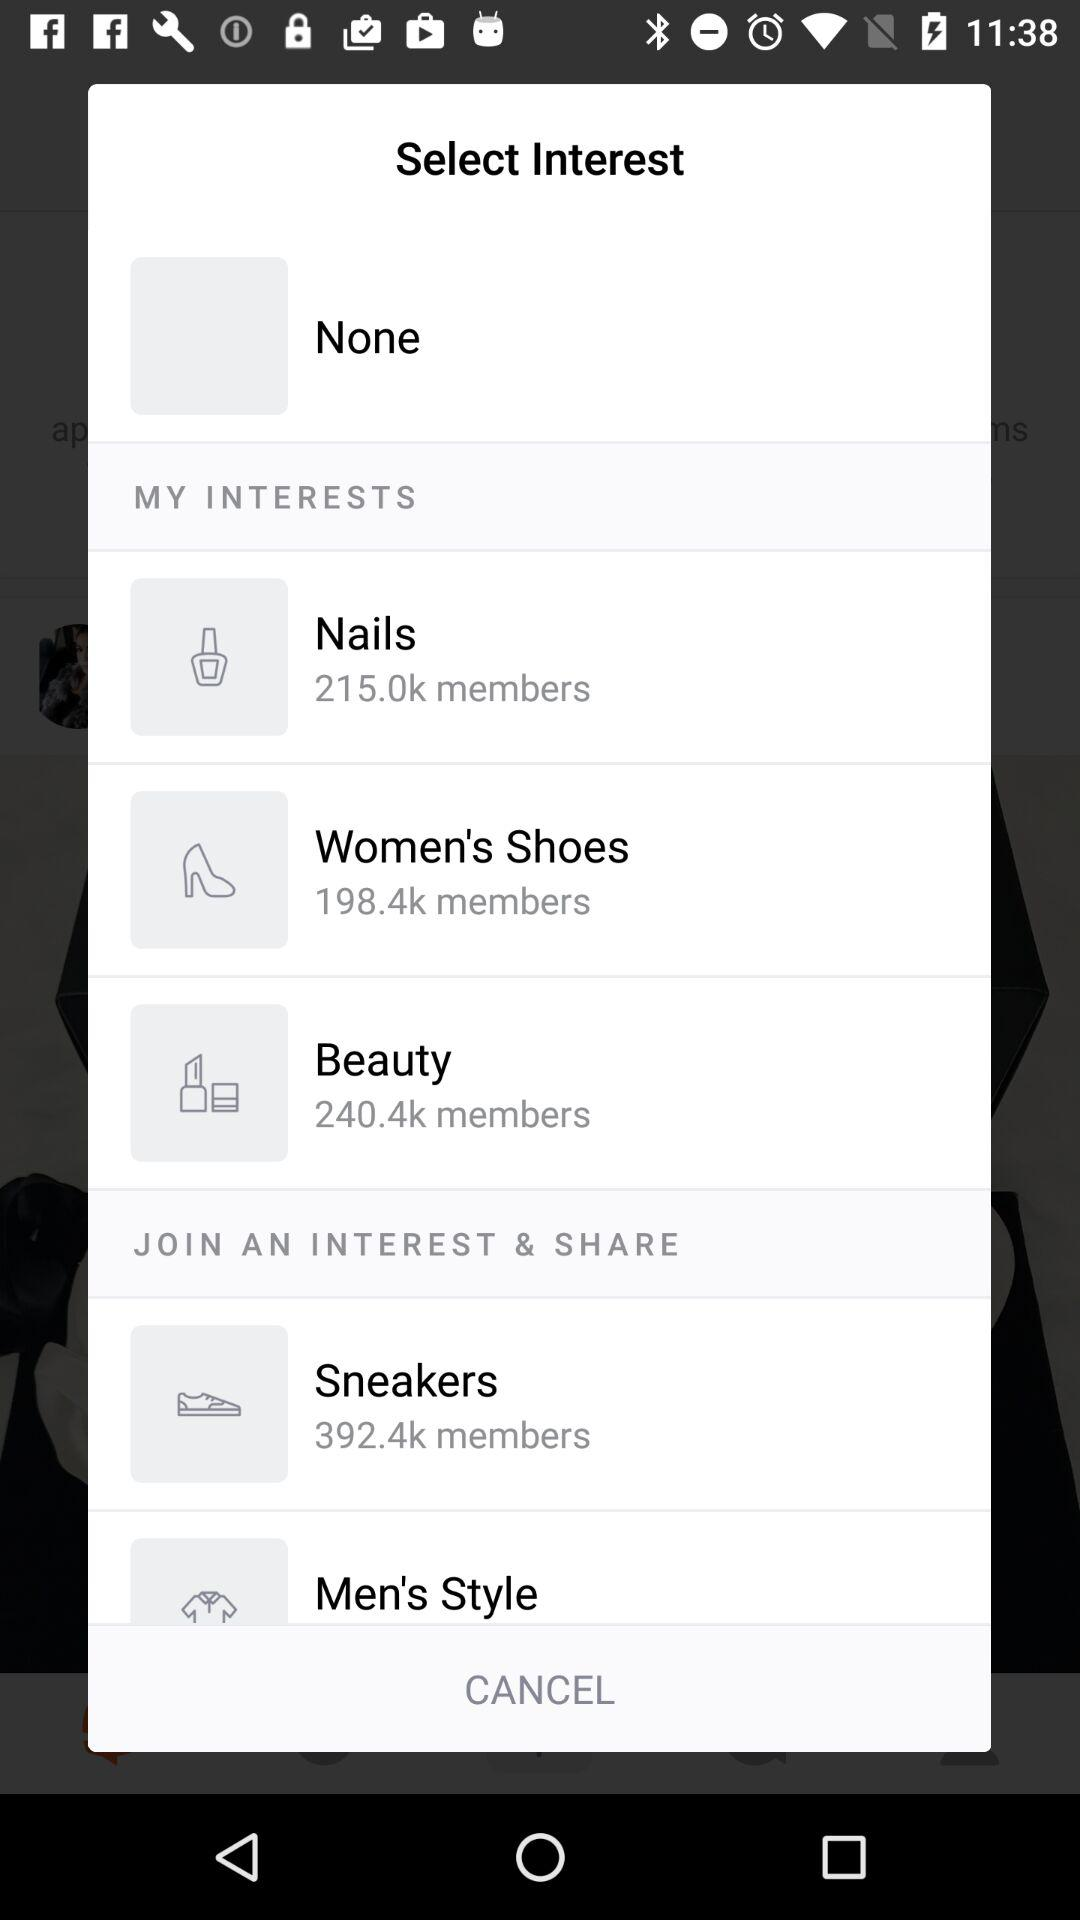How many interests have a member count greater than 200k?
Answer the question using a single word or phrase. 3 